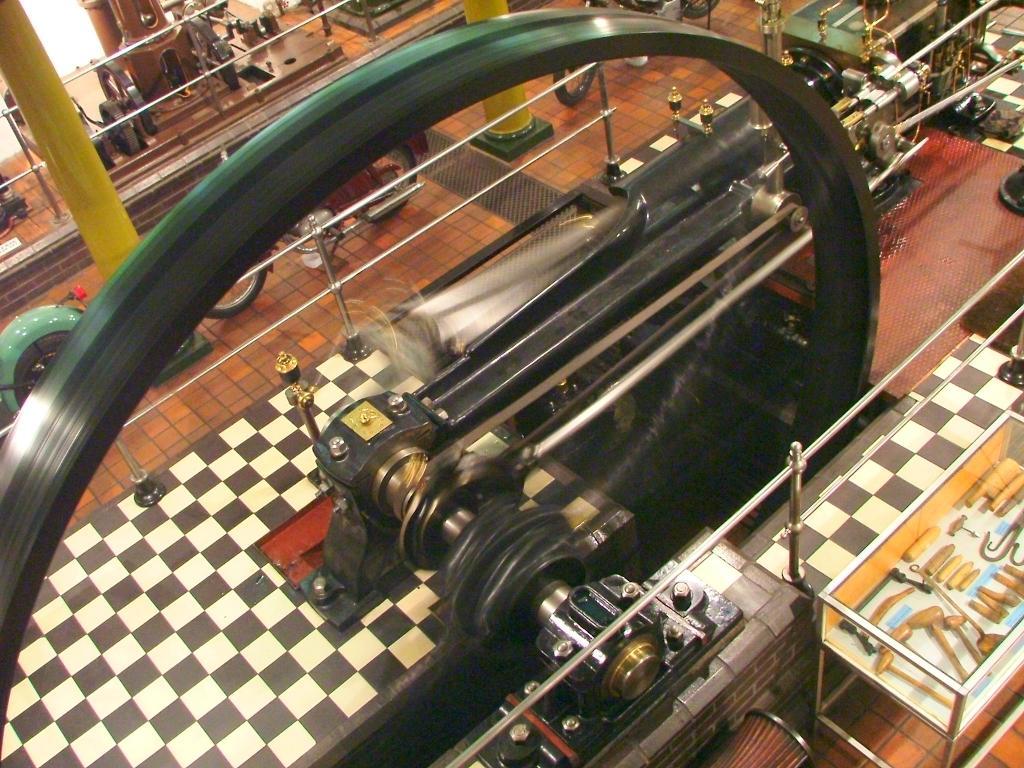In one or two sentences, can you explain what this image depicts? This picture shows a machine. We see a wheel running and we see few motorcycles on the floor and we see wooden tools in a glass box and couple of pillars 